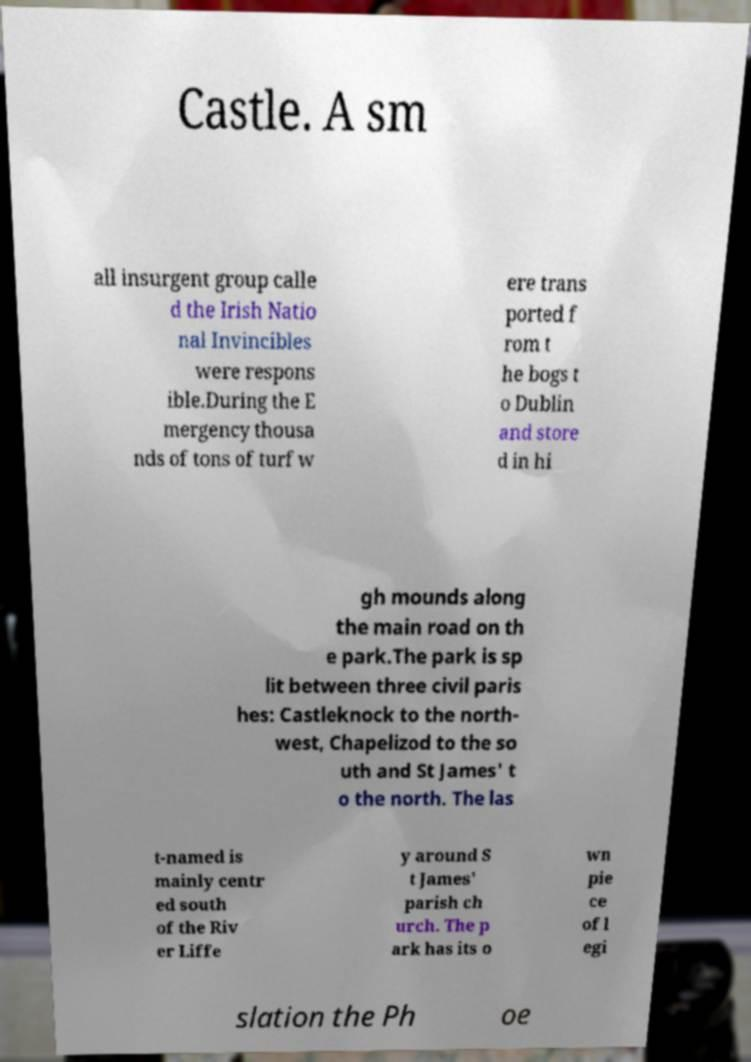There's text embedded in this image that I need extracted. Can you transcribe it verbatim? Castle. A sm all insurgent group calle d the Irish Natio nal Invincibles were respons ible.During the E mergency thousa nds of tons of turf w ere trans ported f rom t he bogs t o Dublin and store d in hi gh mounds along the main road on th e park.The park is sp lit between three civil paris hes: Castleknock to the north- west, Chapelizod to the so uth and St James' t o the north. The las t-named is mainly centr ed south of the Riv er Liffe y around S t James' parish ch urch. The p ark has its o wn pie ce of l egi slation the Ph oe 